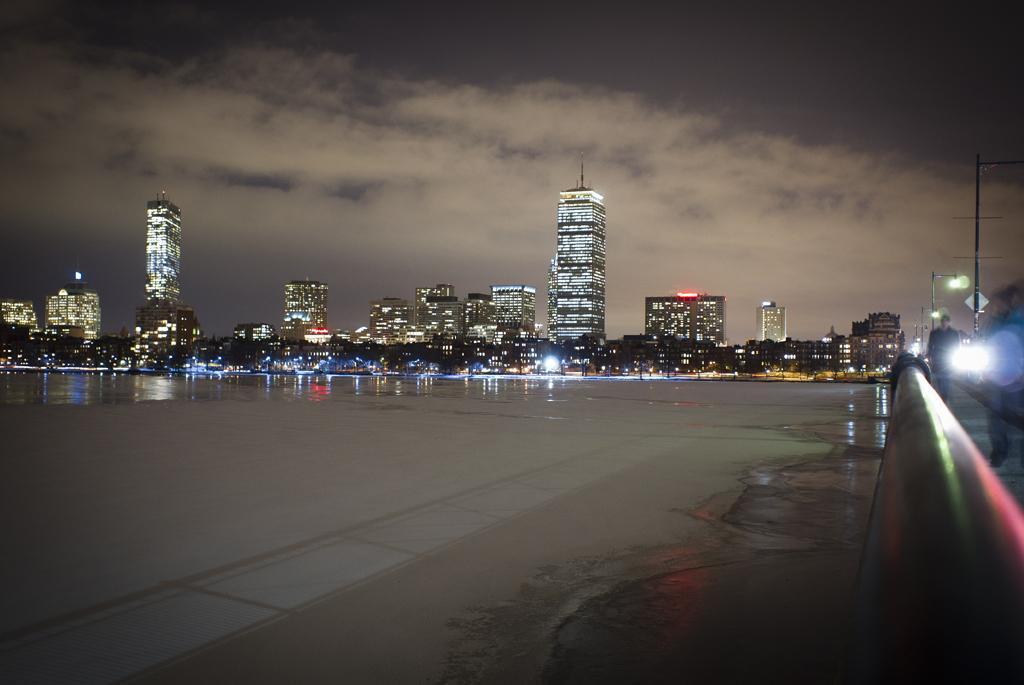Describe this image in one or two sentences. In this image I can see the water surface. On the right side I can see a wall. I can see few buildings. At the top I can see clouds in the sky. 